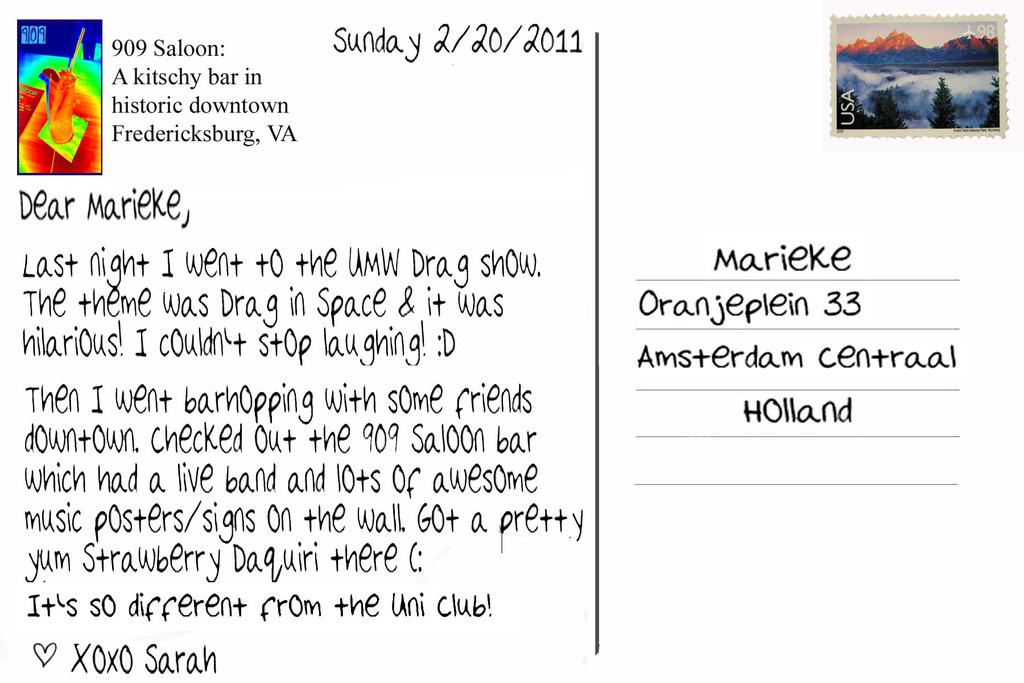What is the main object in the image? There is a stamp paper in the image. Where is the stamp paper located in the image? The stamp paper is on the top right side of the image. What does the stamp paper resemble? The stamp paper resembles a letter. What can be seen on the stamp paper? There is text visible on the stamp paper. What type of hose is being used to start the treatment in the image? There is no hose or treatment present in the image; it only features a stamp paper with text. 